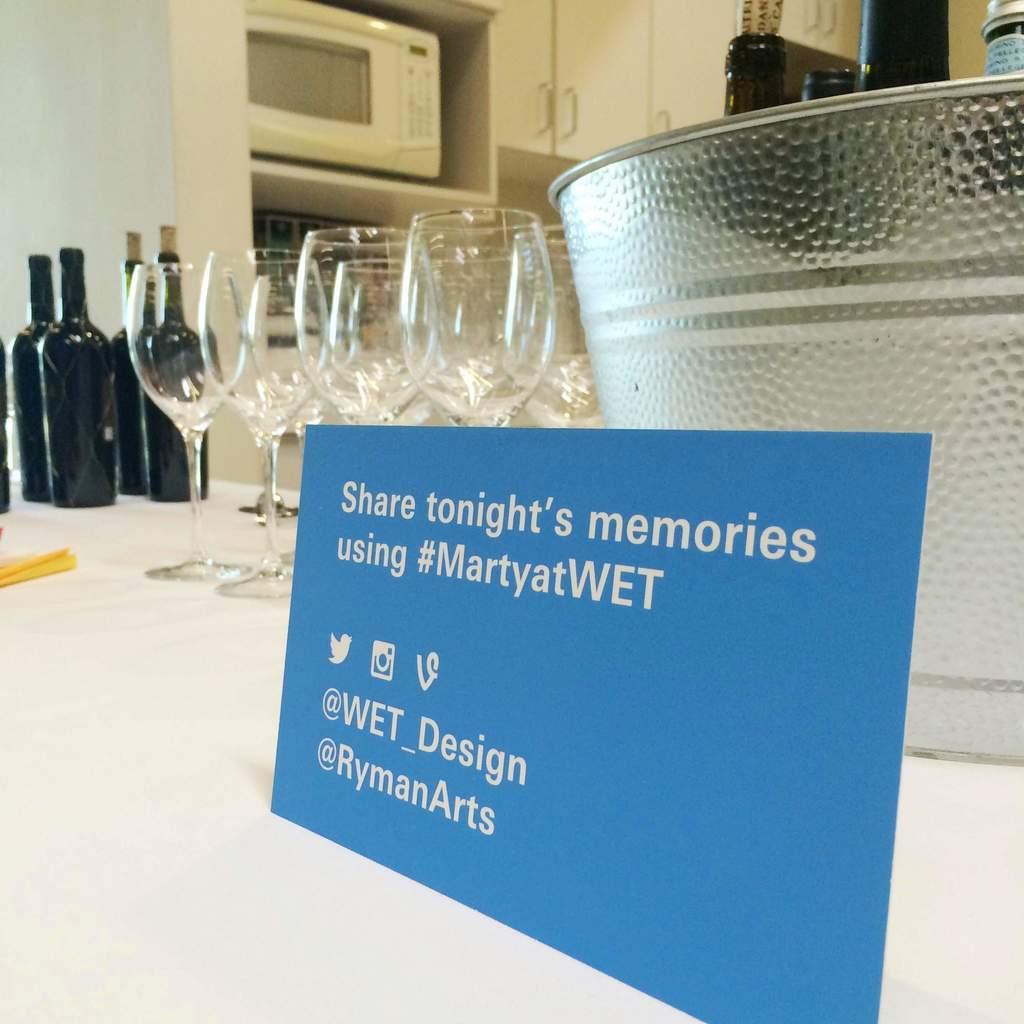Is there a twiiter i can go to for information?
Provide a short and direct response. Yes. Can you also instagram tonights memories?
Ensure brevity in your answer.  Yes. 